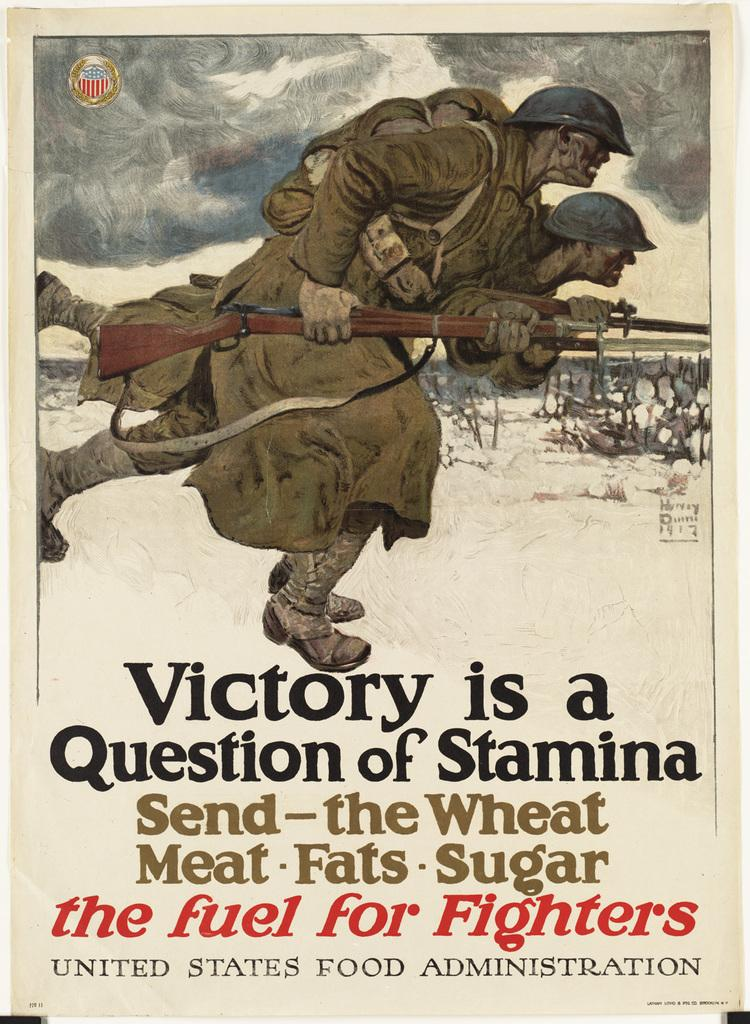<image>
Give a short and clear explanation of the subsequent image. a poster that says 'victory is a question of stamina' onit 